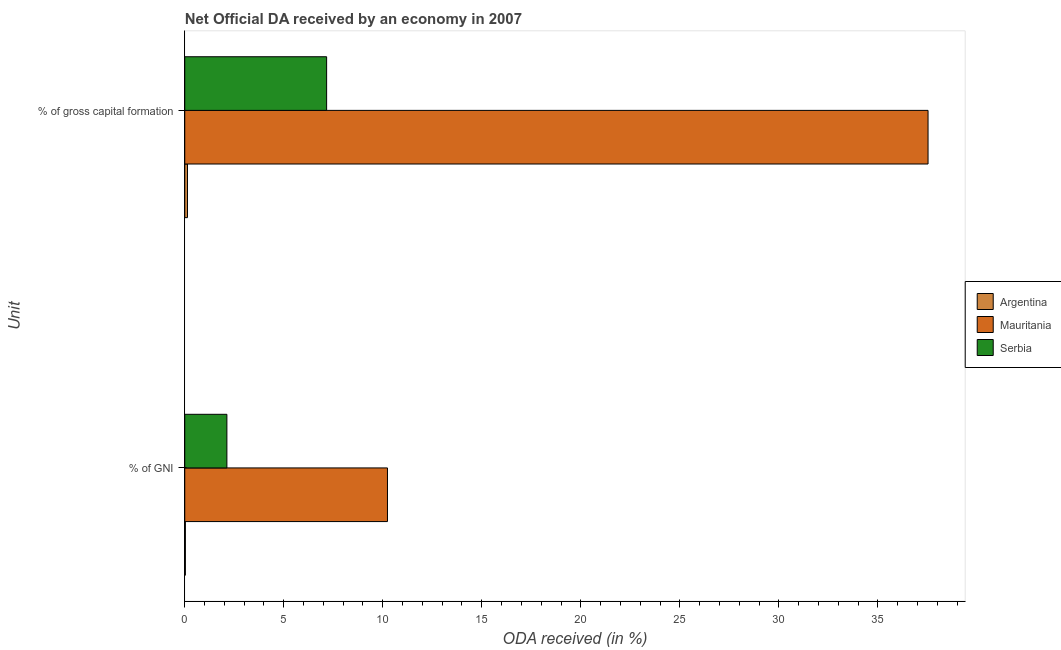Are the number of bars on each tick of the Y-axis equal?
Your answer should be compact. Yes. How many bars are there on the 1st tick from the top?
Give a very brief answer. 3. What is the label of the 2nd group of bars from the top?
Provide a succinct answer. % of GNI. What is the oda received as percentage of gni in Serbia?
Provide a succinct answer. 2.13. Across all countries, what is the maximum oda received as percentage of gross capital formation?
Offer a terse response. 37.54. Across all countries, what is the minimum oda received as percentage of gni?
Your answer should be very brief. 0.03. In which country was the oda received as percentage of gross capital formation maximum?
Offer a very short reply. Mauritania. In which country was the oda received as percentage of gni minimum?
Your response must be concise. Argentina. What is the total oda received as percentage of gni in the graph?
Offer a very short reply. 12.4. What is the difference between the oda received as percentage of gni in Argentina and that in Serbia?
Make the answer very short. -2.1. What is the difference between the oda received as percentage of gni in Serbia and the oda received as percentage of gross capital formation in Argentina?
Give a very brief answer. 1.99. What is the average oda received as percentage of gross capital formation per country?
Your answer should be very brief. 14.95. What is the difference between the oda received as percentage of gross capital formation and oda received as percentage of gni in Argentina?
Ensure brevity in your answer.  0.11. In how many countries, is the oda received as percentage of gross capital formation greater than 38 %?
Offer a terse response. 0. What is the ratio of the oda received as percentage of gross capital formation in Mauritania to that in Serbia?
Ensure brevity in your answer.  5.24. Is the oda received as percentage of gni in Mauritania less than that in Argentina?
Your answer should be compact. No. In how many countries, is the oda received as percentage of gross capital formation greater than the average oda received as percentage of gross capital formation taken over all countries?
Keep it short and to the point. 1. What does the 1st bar from the top in % of gross capital formation represents?
Provide a succinct answer. Serbia. How many bars are there?
Ensure brevity in your answer.  6. Are all the bars in the graph horizontal?
Your response must be concise. Yes. How many countries are there in the graph?
Ensure brevity in your answer.  3. Does the graph contain grids?
Offer a very short reply. No. Where does the legend appear in the graph?
Provide a short and direct response. Center right. What is the title of the graph?
Keep it short and to the point. Net Official DA received by an economy in 2007. What is the label or title of the X-axis?
Provide a short and direct response. ODA received (in %). What is the label or title of the Y-axis?
Your response must be concise. Unit. What is the ODA received (in %) in Argentina in % of GNI?
Ensure brevity in your answer.  0.03. What is the ODA received (in %) in Mauritania in % of GNI?
Offer a terse response. 10.24. What is the ODA received (in %) of Serbia in % of GNI?
Your answer should be very brief. 2.13. What is the ODA received (in %) of Argentina in % of gross capital formation?
Offer a terse response. 0.14. What is the ODA received (in %) of Mauritania in % of gross capital formation?
Your answer should be very brief. 37.54. What is the ODA received (in %) of Serbia in % of gross capital formation?
Your answer should be compact. 7.16. Across all Unit, what is the maximum ODA received (in %) in Argentina?
Give a very brief answer. 0.14. Across all Unit, what is the maximum ODA received (in %) in Mauritania?
Make the answer very short. 37.54. Across all Unit, what is the maximum ODA received (in %) in Serbia?
Offer a terse response. 7.16. Across all Unit, what is the minimum ODA received (in %) of Argentina?
Keep it short and to the point. 0.03. Across all Unit, what is the minimum ODA received (in %) of Mauritania?
Offer a very short reply. 10.24. Across all Unit, what is the minimum ODA received (in %) in Serbia?
Provide a short and direct response. 2.13. What is the total ODA received (in %) of Argentina in the graph?
Keep it short and to the point. 0.17. What is the total ODA received (in %) of Mauritania in the graph?
Offer a very short reply. 47.77. What is the total ODA received (in %) in Serbia in the graph?
Your response must be concise. 9.29. What is the difference between the ODA received (in %) of Argentina in % of GNI and that in % of gross capital formation?
Ensure brevity in your answer.  -0.11. What is the difference between the ODA received (in %) in Mauritania in % of GNI and that in % of gross capital formation?
Keep it short and to the point. -27.3. What is the difference between the ODA received (in %) of Serbia in % of GNI and that in % of gross capital formation?
Give a very brief answer. -5.04. What is the difference between the ODA received (in %) in Argentina in % of GNI and the ODA received (in %) in Mauritania in % of gross capital formation?
Keep it short and to the point. -37.5. What is the difference between the ODA received (in %) of Argentina in % of GNI and the ODA received (in %) of Serbia in % of gross capital formation?
Offer a very short reply. -7.13. What is the difference between the ODA received (in %) of Mauritania in % of GNI and the ODA received (in %) of Serbia in % of gross capital formation?
Give a very brief answer. 3.07. What is the average ODA received (in %) of Argentina per Unit?
Make the answer very short. 0.08. What is the average ODA received (in %) of Mauritania per Unit?
Offer a very short reply. 23.89. What is the average ODA received (in %) of Serbia per Unit?
Ensure brevity in your answer.  4.65. What is the difference between the ODA received (in %) in Argentina and ODA received (in %) in Mauritania in % of GNI?
Give a very brief answer. -10.21. What is the difference between the ODA received (in %) of Argentina and ODA received (in %) of Serbia in % of GNI?
Make the answer very short. -2.1. What is the difference between the ODA received (in %) of Mauritania and ODA received (in %) of Serbia in % of GNI?
Your answer should be compact. 8.11. What is the difference between the ODA received (in %) in Argentina and ODA received (in %) in Mauritania in % of gross capital formation?
Make the answer very short. -37.4. What is the difference between the ODA received (in %) in Argentina and ODA received (in %) in Serbia in % of gross capital formation?
Provide a short and direct response. -7.03. What is the difference between the ODA received (in %) in Mauritania and ODA received (in %) in Serbia in % of gross capital formation?
Your answer should be very brief. 30.37. What is the ratio of the ODA received (in %) in Argentina in % of GNI to that in % of gross capital formation?
Ensure brevity in your answer.  0.23. What is the ratio of the ODA received (in %) of Mauritania in % of GNI to that in % of gross capital formation?
Offer a very short reply. 0.27. What is the ratio of the ODA received (in %) in Serbia in % of GNI to that in % of gross capital formation?
Keep it short and to the point. 0.3. What is the difference between the highest and the second highest ODA received (in %) of Argentina?
Provide a short and direct response. 0.11. What is the difference between the highest and the second highest ODA received (in %) in Mauritania?
Ensure brevity in your answer.  27.3. What is the difference between the highest and the second highest ODA received (in %) of Serbia?
Offer a terse response. 5.04. What is the difference between the highest and the lowest ODA received (in %) of Argentina?
Offer a terse response. 0.11. What is the difference between the highest and the lowest ODA received (in %) of Mauritania?
Your answer should be very brief. 27.3. What is the difference between the highest and the lowest ODA received (in %) of Serbia?
Your response must be concise. 5.04. 